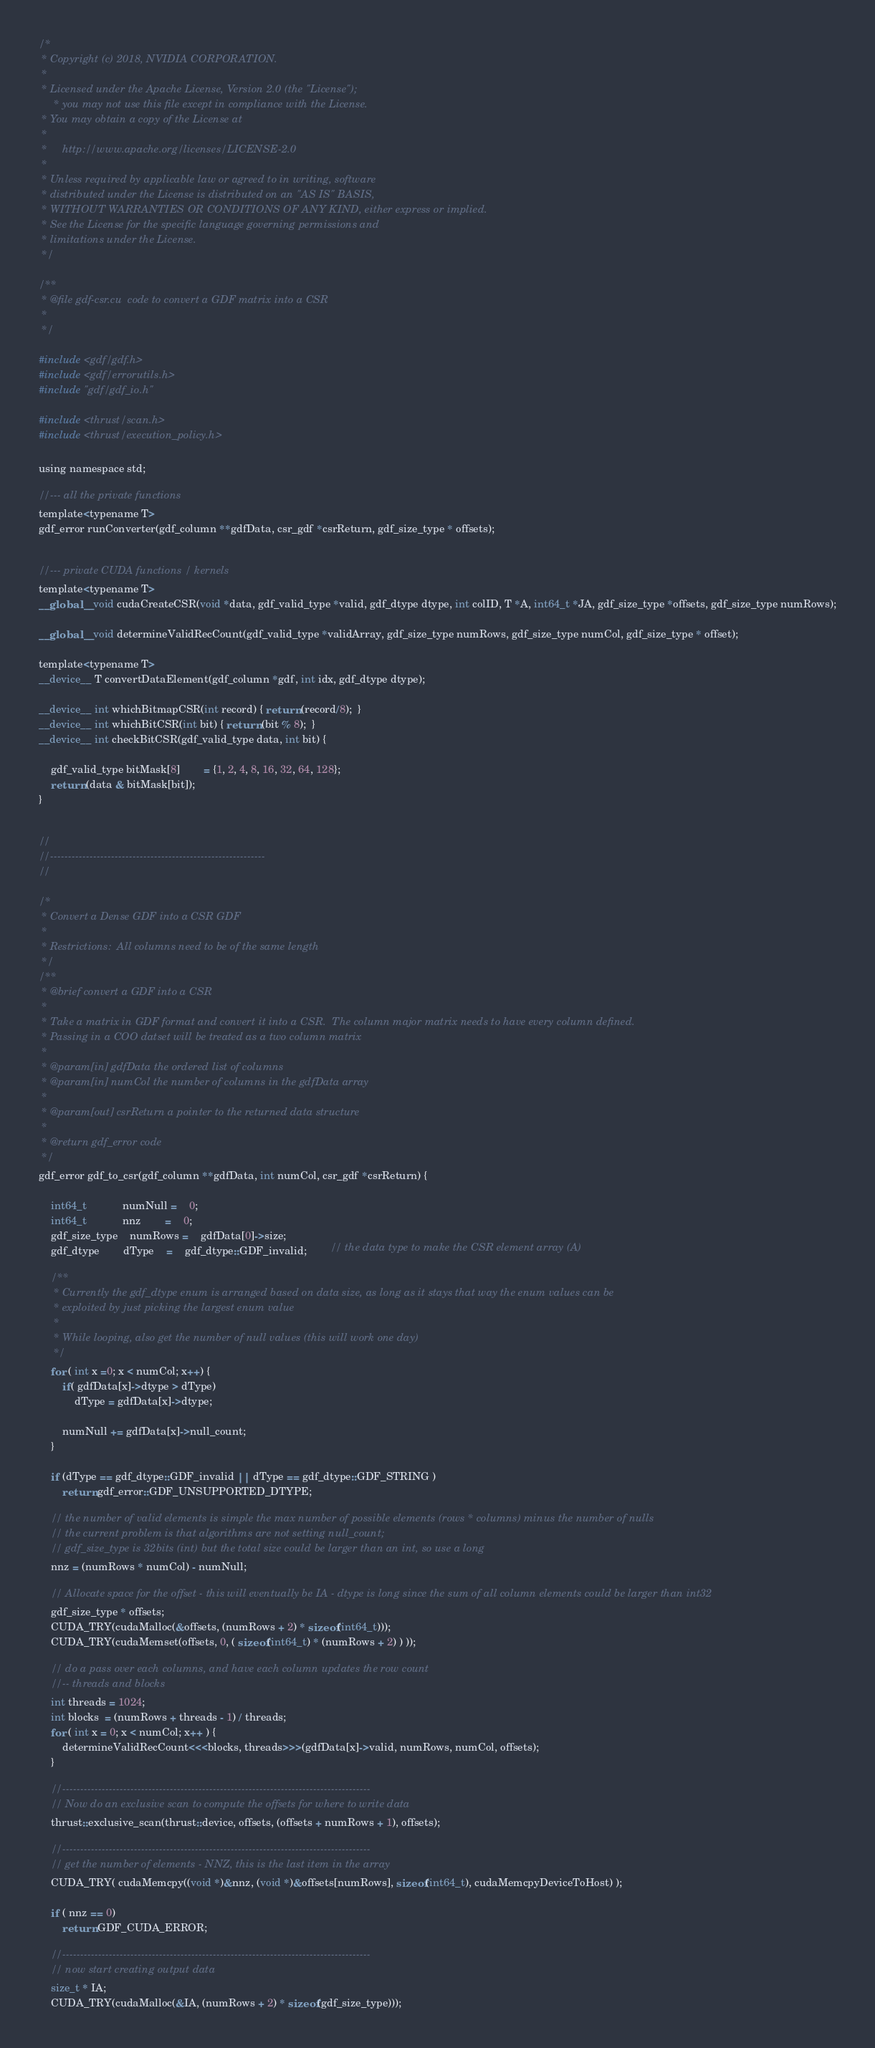Convert code to text. <code><loc_0><loc_0><loc_500><loc_500><_Cuda_>/*
 * Copyright (c) 2018, NVIDIA CORPORATION.
 *
 * Licensed under the Apache License, Version 2.0 (the "License");
	 * you may not use this file except in compliance with the License.
 * You may obtain a copy of the License at
 *
 *     http://www.apache.org/licenses/LICENSE-2.0
 *
 * Unless required by applicable law or agreed to in writing, software
 * distributed under the License is distributed on an "AS IS" BASIS,
 * WITHOUT WARRANTIES OR CONDITIONS OF ANY KIND, either express or implied.
 * See the License for the specific language governing permissions and
 * limitations under the License.
 */

/**
 * @file gdf-csr.cu  code to convert a GDF matrix into a CSR
 *
 */

#include <gdf/gdf.h>
#include <gdf/errorutils.h>
#include "gdf/gdf_io.h"

#include <thrust/scan.h>
#include <thrust/execution_policy.h>

using namespace std;

//--- all the private functions
template<typename T>
gdf_error runConverter(gdf_column **gdfData, csr_gdf *csrReturn, gdf_size_type * offsets);


//--- private CUDA functions / kernels
template<typename T>
__global__ void cudaCreateCSR(void *data, gdf_valid_type *valid, gdf_dtype dtype, int colID, T *A, int64_t *JA, gdf_size_type *offsets, gdf_size_type numRows);

__global__ void determineValidRecCount(gdf_valid_type *validArray, gdf_size_type numRows, gdf_size_type numCol, gdf_size_type * offset);

template<typename T>
__device__ T convertDataElement(gdf_column *gdf, int idx, gdf_dtype dtype);

__device__ int whichBitmapCSR(int record) { return (record/8);  }
__device__ int whichBitCSR(int bit) { return (bit % 8);  }
__device__ int checkBitCSR(gdf_valid_type data, int bit) {

	gdf_valid_type bitMask[8] 		= {1, 2, 4, 8, 16, 32, 64, 128};
	return (data & bitMask[bit]);
}


//
//------------------------------------------------------------
//

/*
 * Convert a Dense GDF into a CSR GDF
 *
 * Restrictions:  All columns need to be of the same length
 */
/**
 * @brief convert a GDF into a CSR
 *
 * Take a matrix in GDF format and convert it into a CSR.  The column major matrix needs to have every column defined.
 * Passing in a COO datset will be treated as a two column matrix
 *
 * @param[in] gdfData the ordered list of columns
 * @param[in] numCol the number of columns in the gdfData array
 *
 * @param[out] csrReturn a pointer to the returned data structure
 *
 * @return gdf_error code
 */
gdf_error gdf_to_csr(gdf_column **gdfData, int numCol, csr_gdf *csrReturn) {

	int64_t			numNull = 	0;
	int64_t			nnz		= 	0;
	gdf_size_type	numRows =	gdfData[0]->size;
	gdf_dtype		dType	=	gdf_dtype::GDF_invalid;		// the data type to make the CSR element array (A)

	/**
	 * Currently the gdf_dtype enum is arranged based on data size, as long as it stays that way the enum values can be
	 * exploited by just picking the largest enum value
	 *
	 * While looping, also get the number of null values (this will work one day)
	 */
	for ( int x =0; x < numCol; x++) {
		if( gdfData[x]->dtype > dType)
			dType = gdfData[x]->dtype;

		numNull += gdfData[x]->null_count;
	}

	if (dType == gdf_dtype::GDF_invalid || dType == gdf_dtype::GDF_STRING )
		return gdf_error::GDF_UNSUPPORTED_DTYPE;

	// the number of valid elements is simple the max number of possible elements (rows * columns) minus the number of nulls
	// the current problem is that algorithms are not setting null_count;
	// gdf_size_type is 32bits (int) but the total size could be larger than an int, so use a long
	nnz = (numRows * numCol) - numNull;

	// Allocate space for the offset - this will eventually be IA - dtype is long since the sum of all column elements could be larger than int32
	gdf_size_type * offsets;
    CUDA_TRY(cudaMalloc(&offsets, (numRows + 2) * sizeof(int64_t)));
    CUDA_TRY(cudaMemset(offsets, 0, ( sizeof(int64_t) * (numRows + 2) ) ));

    // do a pass over each columns, and have each column updates the row count
	//-- threads and blocks
    int threads = 1024;
    int blocks  = (numRows + threads - 1) / threads;
	for ( int x = 0; x < numCol; x++ ) {
		determineValidRecCount<<<blocks, threads>>>(gdfData[x]->valid, numRows, numCol, offsets);
	}

	//--------------------------------------------------------------------------------------
	// Now do an exclusive scan to compute the offsets for where to write data
    thrust::exclusive_scan(thrust::device, offsets, (offsets + numRows + 1), offsets);

	//--------------------------------------------------------------------------------------
    // get the number of elements - NNZ, this is the last item in the array
    CUDA_TRY( cudaMemcpy((void *)&nnz, (void *)&offsets[numRows], sizeof(int64_t), cudaMemcpyDeviceToHost) );

	if ( nnz == 0)
		return GDF_CUDA_ERROR;

	//--------------------------------------------------------------------------------------
	// now start creating output data
    size_t * IA;
    CUDA_TRY(cudaMalloc(&IA, (numRows + 2) * sizeof(gdf_size_type)));</code> 